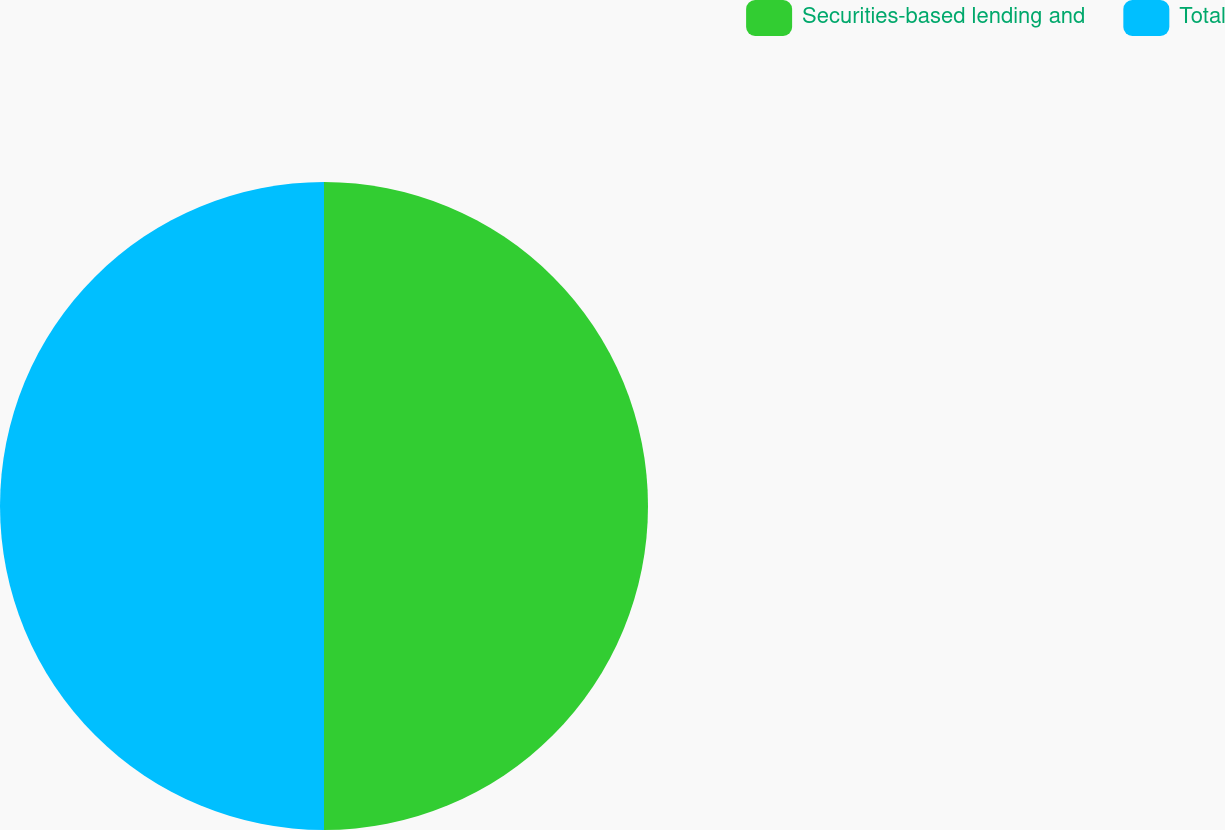Convert chart. <chart><loc_0><loc_0><loc_500><loc_500><pie_chart><fcel>Securities-based lending and<fcel>Total<nl><fcel>50.0%<fcel>50.0%<nl></chart> 